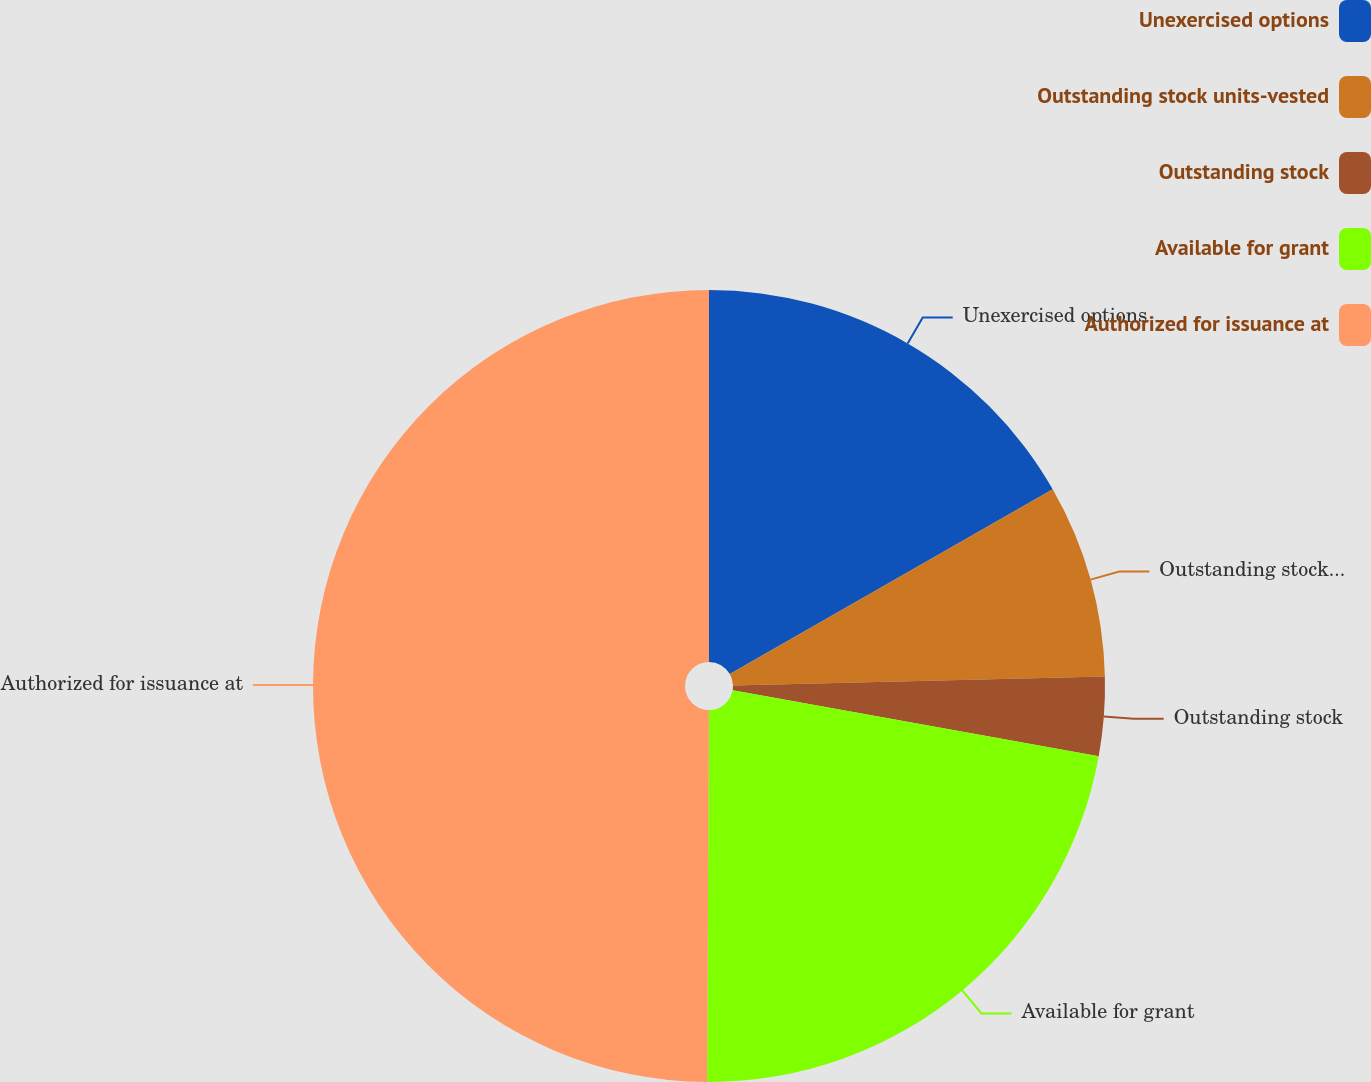<chart> <loc_0><loc_0><loc_500><loc_500><pie_chart><fcel>Unexercised options<fcel>Outstanding stock units-vested<fcel>Outstanding stock<fcel>Available for grant<fcel>Authorized for issuance at<nl><fcel>16.73%<fcel>7.89%<fcel>3.22%<fcel>22.24%<fcel>49.93%<nl></chart> 